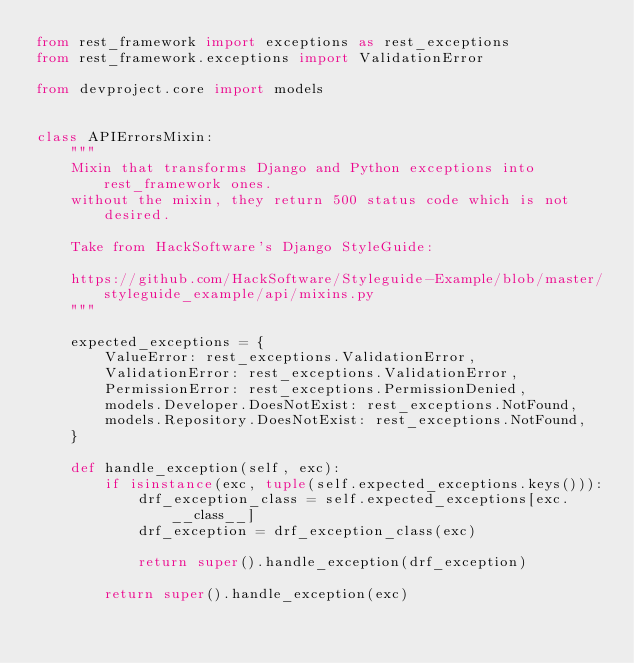Convert code to text. <code><loc_0><loc_0><loc_500><loc_500><_Python_>from rest_framework import exceptions as rest_exceptions
from rest_framework.exceptions import ValidationError

from devproject.core import models


class APIErrorsMixin:
    """
    Mixin that transforms Django and Python exceptions into rest_framework ones.
    without the mixin, they return 500 status code which is not desired.

    Take from HackSoftware's Django StyleGuide:

    https://github.com/HackSoftware/Styleguide-Example/blob/master/styleguide_example/api/mixins.py
    """

    expected_exceptions = {
        ValueError: rest_exceptions.ValidationError,
        ValidationError: rest_exceptions.ValidationError,
        PermissionError: rest_exceptions.PermissionDenied,
        models.Developer.DoesNotExist: rest_exceptions.NotFound,
        models.Repository.DoesNotExist: rest_exceptions.NotFound,
    }

    def handle_exception(self, exc):
        if isinstance(exc, tuple(self.expected_exceptions.keys())):
            drf_exception_class = self.expected_exceptions[exc.__class__]
            drf_exception = drf_exception_class(exc)

            return super().handle_exception(drf_exception)

        return super().handle_exception(exc)
</code> 